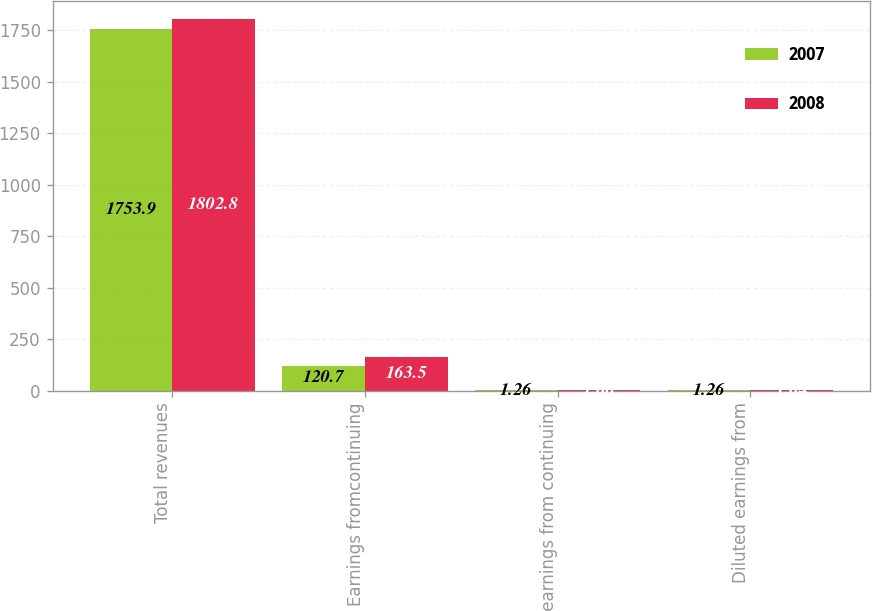Convert chart. <chart><loc_0><loc_0><loc_500><loc_500><stacked_bar_chart><ecel><fcel>Total revenues<fcel>Earnings fromcontinuing<fcel>Basic earnings from continuing<fcel>Diluted earnings from<nl><fcel>2007<fcel>1753.9<fcel>120.7<fcel>1.26<fcel>1.26<nl><fcel>2008<fcel>1802.8<fcel>163.5<fcel>1.66<fcel>1.64<nl></chart> 